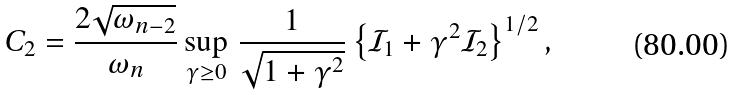Convert formula to latex. <formula><loc_0><loc_0><loc_500><loc_500>C _ { 2 } = \frac { 2 \sqrt { \omega _ { n - 2 } } } { \omega _ { n } } \sup _ { \gamma \geq 0 } \, \frac { 1 } { \sqrt { 1 + \gamma ^ { 2 } } } \left \{ { \mathcal { I } } _ { 1 } + \gamma ^ { 2 } { \mathcal { I } } _ { 2 } \right \} ^ { 1 / 2 } ,</formula> 